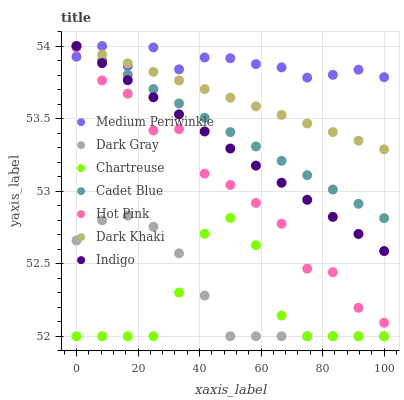Does Chartreuse have the minimum area under the curve?
Answer yes or no. Yes. Does Medium Periwinkle have the maximum area under the curve?
Answer yes or no. Yes. Does Cadet Blue have the minimum area under the curve?
Answer yes or no. No. Does Cadet Blue have the maximum area under the curve?
Answer yes or no. No. Is Cadet Blue the smoothest?
Answer yes or no. Yes. Is Hot Pink the roughest?
Answer yes or no. Yes. Is Indigo the smoothest?
Answer yes or no. No. Is Indigo the roughest?
Answer yes or no. No. Does Dark Gray have the lowest value?
Answer yes or no. Yes. Does Cadet Blue have the lowest value?
Answer yes or no. No. Does Medium Periwinkle have the highest value?
Answer yes or no. Yes. Does Hot Pink have the highest value?
Answer yes or no. No. Is Dark Gray less than Medium Periwinkle?
Answer yes or no. Yes. Is Medium Periwinkle greater than Dark Gray?
Answer yes or no. Yes. Does Cadet Blue intersect Indigo?
Answer yes or no. Yes. Is Cadet Blue less than Indigo?
Answer yes or no. No. Is Cadet Blue greater than Indigo?
Answer yes or no. No. Does Dark Gray intersect Medium Periwinkle?
Answer yes or no. No. 